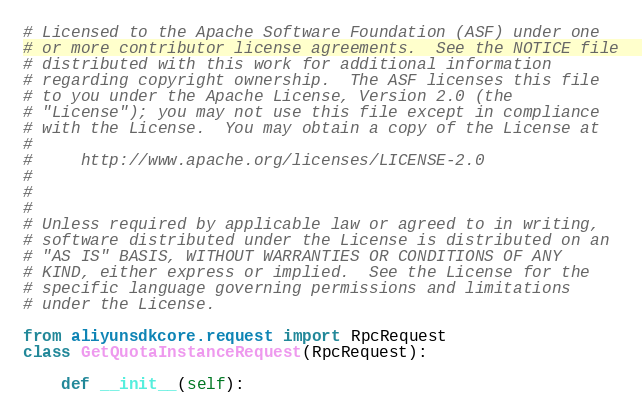Convert code to text. <code><loc_0><loc_0><loc_500><loc_500><_Python_># Licensed to the Apache Software Foundation (ASF) under one
# or more contributor license agreements.  See the NOTICE file
# distributed with this work for additional information
# regarding copyright ownership.  The ASF licenses this file
# to you under the Apache License, Version 2.0 (the
# "License"); you may not use this file except in compliance
# with the License.  You may obtain a copy of the License at
#
#     http://www.apache.org/licenses/LICENSE-2.0
#
#
#
# Unless required by applicable law or agreed to in writing,
# software distributed under the License is distributed on an
# "AS IS" BASIS, WITHOUT WARRANTIES OR CONDITIONS OF ANY
# KIND, either express or implied.  See the License for the
# specific language governing permissions and limitations
# under the License.

from aliyunsdkcore.request import RpcRequest
class GetQuotaInstanceRequest(RpcRequest):

	def __init__(self):</code> 